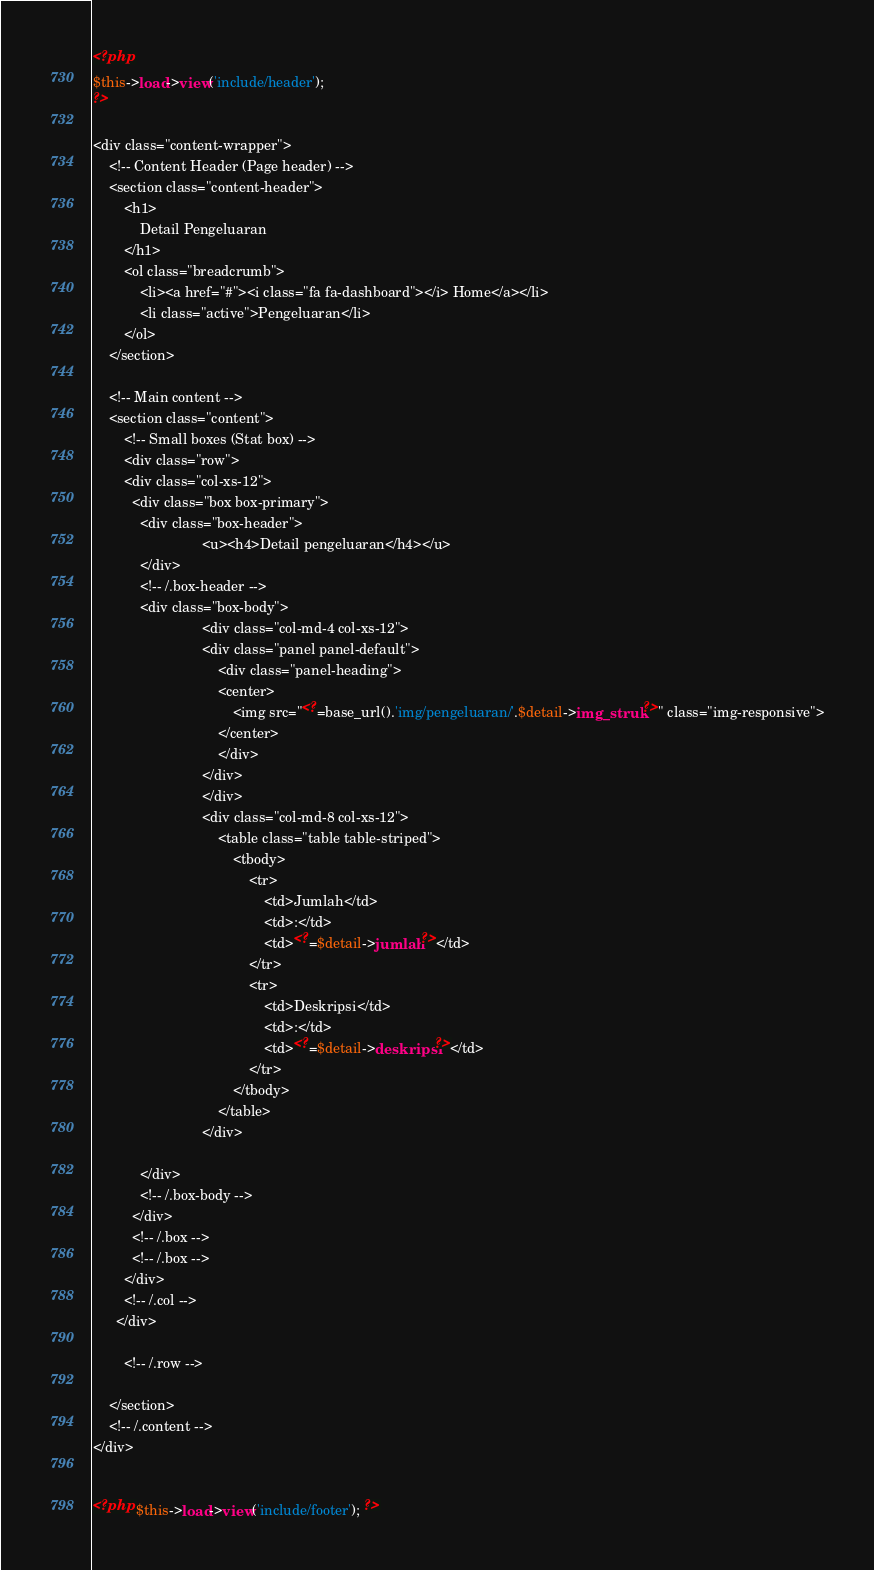Convert code to text. <code><loc_0><loc_0><loc_500><loc_500><_PHP_><?php
$this->load->view('include/header');
?>

<div class="content-wrapper">
	<!-- Content Header (Page header) -->
	<section class="content-header">
		<h1>
			Detail Pengeluaran
		</h1>
		<ol class="breadcrumb">
			<li><a href="#"><i class="fa fa-dashboard"></i> Home</a></li>
			<li class="active">Pengeluaran</li>
		</ol>
	</section>

	<!-- Main content -->
	<section class="content">
		<!-- Small boxes (Stat box) -->
		<div class="row">
        <div class="col-xs-12">
          <div class="box box-primary">
            <div class="box-header">
							<u><h4>Detail pengeluaran</h4></u>
            </div>
            <!-- /.box-header -->
            <div class="box-body">
							<div class="col-md-4 col-xs-12">
							<div class="panel panel-default">
								<div class="panel-heading">
								<center>
									<img src="<?=base_url().'img/pengeluaran/'.$detail->img_struk?>" class="img-responsive">
								</center>
								</div>
							</div>
							</div>
							<div class="col-md-8 col-xs-12">
								<table class="table table-striped">
									<tbody>
										<tr>
											<td>Jumlah</td>
											<td>:</td>
											<td><?=$detail->jumlah?></td>
										</tr>
										<tr>
											<td>Deskripsi</td>
											<td>:</td>
											<td><?=$detail->deskripsi?></td>
										</tr>
									</tbody>
								</table>
							</div>

            </div>
            <!-- /.box-body -->
          </div>
          <!-- /.box -->
          <!-- /.box -->
        </div>
        <!-- /.col -->
      </div>

		<!-- /.row -->

	</section>
	<!-- /.content -->
</div>


<?php $this->load->view('include/footer'); ?>
</code> 